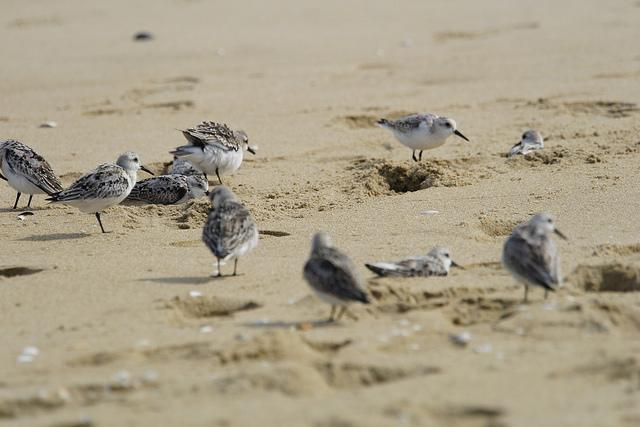What do people usually feed these animals? bread 